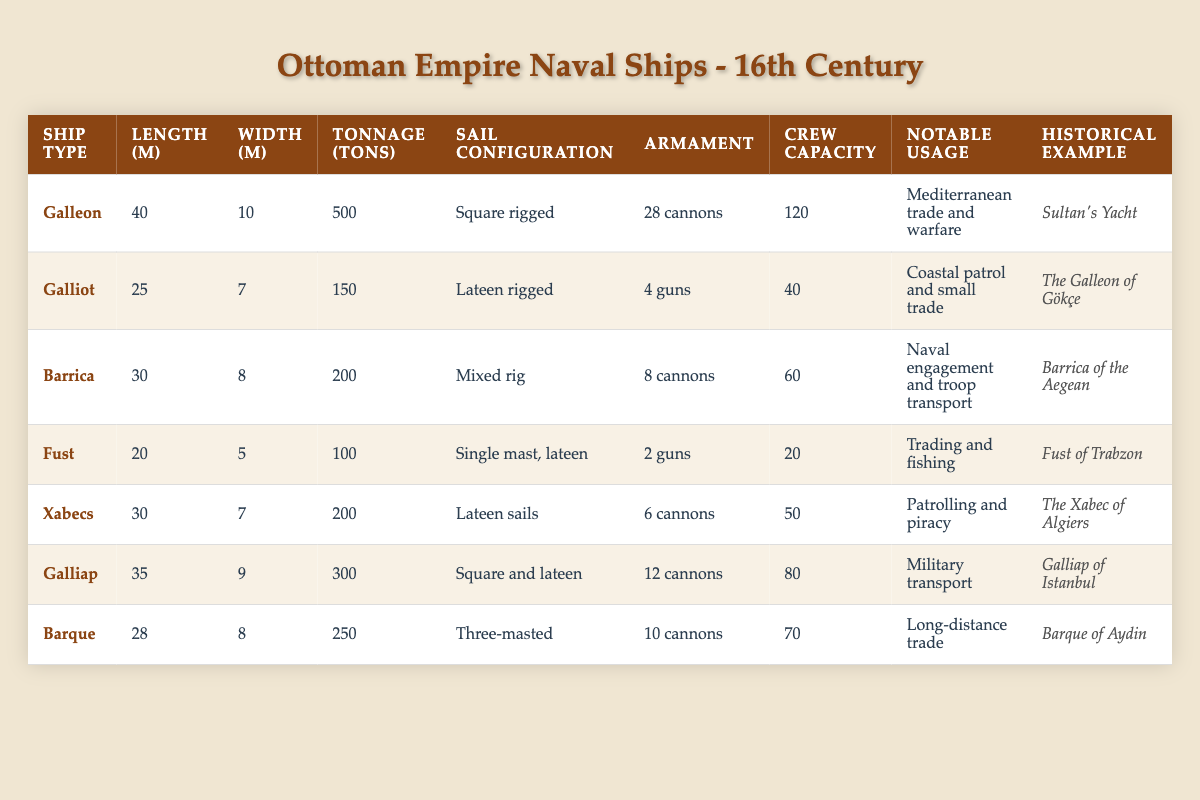What is the length of the Galleon? The Galleon is listed in the table with a length of 40 meters.
Answer: 40 m Which ship type has the highest crew capacity? By checking the 'Crew Capacity' column, the Galleon has the highest crew capacity at 120.
Answer: Galleon What is the total tonnage of all ship types combined? Adding the tonnage: 500 (Galleon) + 150 (Galliot) + 200 (Barrica) + 100 (Fust) + 200 (Xabecs) + 300 (Galliap) + 250 (Barque) = 1700 tons
Answer: 1700 tons How many cannons are on the Barque? The table shows that the Barque is armed with 10 cannons.
Answer: 10 cannons Which ship type has a mixed sail configuration? The Barrica is identified in the table as having a mixed rig configuration.
Answer: Barrica What is the average length of the ships listed? To find the average length, add all lengths: (40 + 25 + 30 + 20 + 30 + 35 + 28) = 238 meters, then divide by the number of ships (7): 238/7 = 34
Answer: 34 m Is the Fust armed with more than 2 guns? The Fust is noted to have 2 guns, which means it is not armed with more than 2 guns.
Answer: No What ship type is used for Mediterranean trade and warfare? The Galleon is specifically noted for its usage in Mediterranean trade and warfare.
Answer: Galleon Which ship type has the smallest crew capacity, and what is that capacity? The Fust has the smallest crew capacity at 20, as seen in the 'Crew Capacity' column.
Answer: 20 How many ships have an armament of 6 cannons or more? The Galleon, Barrica, Galliap, and Xabecs have armaments of 6 cannons or more: Total = 4 ships.
Answer: 4 ships Which ship has the largest width? The Galleon has a width of 10 meters, which is the largest among the ships listed.
Answer: Galleon What is the notable usage of the Galliap? The notable usage of the Galliap is for military transport according to the data.
Answer: Military transport 